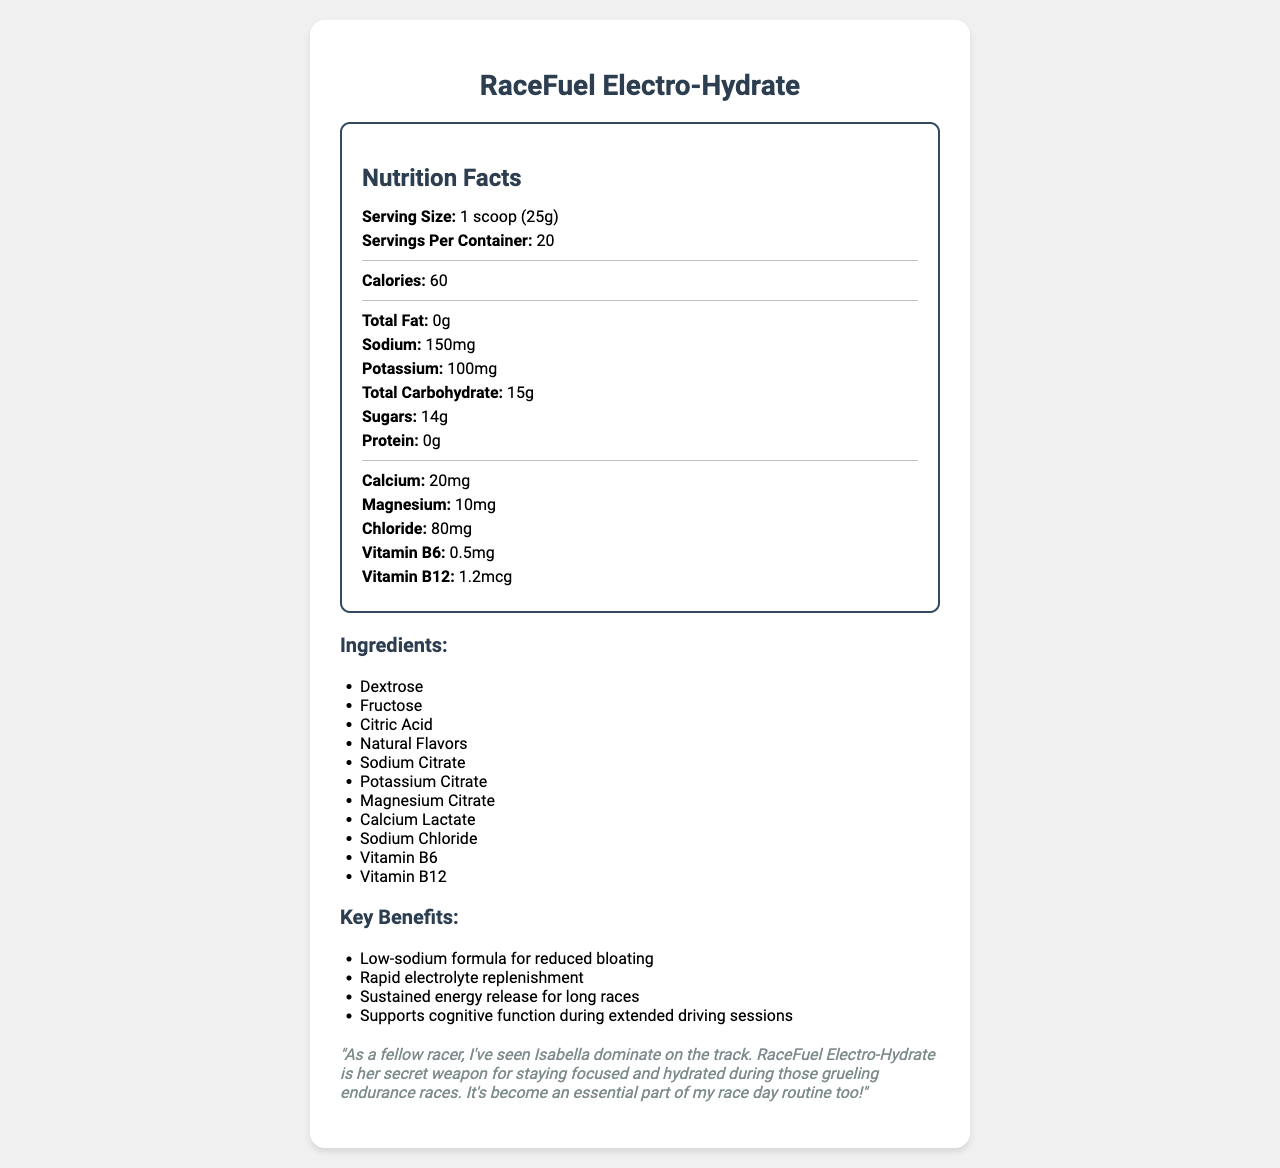what is the serving size? The document mentions the serving size as "1 scoop (25g)" under the "Nutrition Facts" section.
Answer: 1 scoop (25g) how many servings are in each container? The "servings per container" is listed as 20 in the document.
Answer: 20 what flavors are available? The document lists the available flavors in a bullet-point format under the "flavors" section.
Answer: Lemon-Lime Burst, Orange Zest, Berry Blast what is the main carbohydrate source of the drink? The ingredients list contains Dextrose and Fructose, which are common sources of carbohydrates.
Answer: Dextrose and Fructose how much sodium does each serving contain? The sodium content per serving is listed as 150 mg in the "Nutrition Facts" section.
Answer: 150 mg what certifications does this product have? The product is certified as "NSF Certified for Sport" and "Informed-Sport Tested," as noted towards the end of the document.
Answer: NSF Certified for Sport, Informed-Sport Tested who provides the pro testimonial? The testimonial section mentions "A fellow racer" who has seen Isabella dominate on the track.
Answer: A fellow professional car racer what is the total carbohydrate content? A. 12 g B. 15 g C. 18 g D. 25 g The total carbohydrate content per serving is listed as 15 g in the "Nutrition Facts" section.
Answer: B what key benefit does this drink offer specifically for cognitive function? i. Low-sodium formula ii. Rapid electrolyte replenishment iii. Sustained energy release iv. Supports cognitive function during extended driving sessions "Supports cognitive function during extended driving sessions" is one of the key benefits listed in the document.
Answer: iv is this product designed to be consumed during races? The usage instructions state, "Consume every 60-90 minutes during races or as needed for optimal hydration," indicating that it is designed to be consumed during races.
Answer: Yes summarize the main features of the RaceFuel Electro-Hydrate sports drink mix. The document describes the product as a sports drink mix with low sodium, added electrolytes, and features designed to improve hydration, energy, and cognitive function during endurance races. It comes in several flavors and has sport certifications.
Answer: RaceFuel Electro-Hydrate is a low-sodium, electrolyte-rich sports drink mix designed for hydration and sustained energy release during long races. It comes in multiple flavors, offers various benefits like rapid electrolyte replenishment and supporting cognitive function, and is certified for sport. The packaging includes a resealable pouch with a measuring scoop. what is the price of the product? The document does not provide any information about the price of the product.
Answer: Cannot be determined 